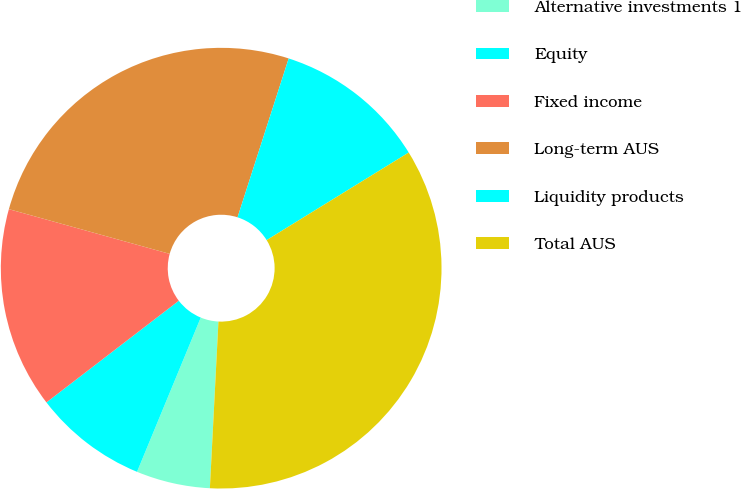Convert chart. <chart><loc_0><loc_0><loc_500><loc_500><pie_chart><fcel>Alternative investments 1<fcel>Equity<fcel>Fixed income<fcel>Long-term AUS<fcel>Liquidity products<fcel>Total AUS<nl><fcel>5.42%<fcel>8.34%<fcel>14.74%<fcel>25.64%<fcel>11.25%<fcel>34.61%<nl></chart> 